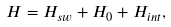Convert formula to latex. <formula><loc_0><loc_0><loc_500><loc_500>H = H _ { s w } + H _ { 0 } + H _ { i n t } ,</formula> 